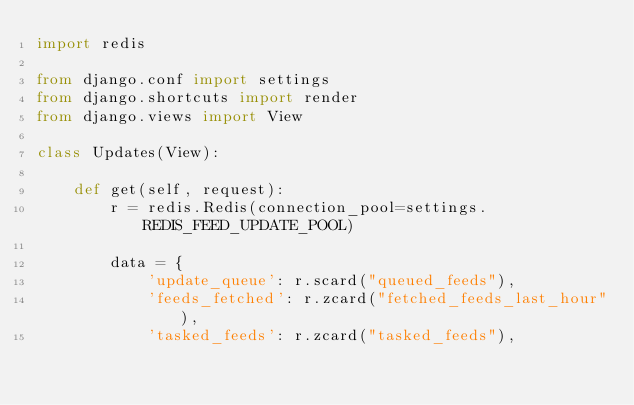Convert code to text. <code><loc_0><loc_0><loc_500><loc_500><_Python_>import redis

from django.conf import settings
from django.shortcuts import render
from django.views import View

class Updates(View):

    def get(self, request):    
        r = redis.Redis(connection_pool=settings.REDIS_FEED_UPDATE_POOL)

        data = {
            'update_queue': r.scard("queued_feeds"),
            'feeds_fetched': r.zcard("fetched_feeds_last_hour"),
            'tasked_feeds': r.zcard("tasked_feeds"),</code> 